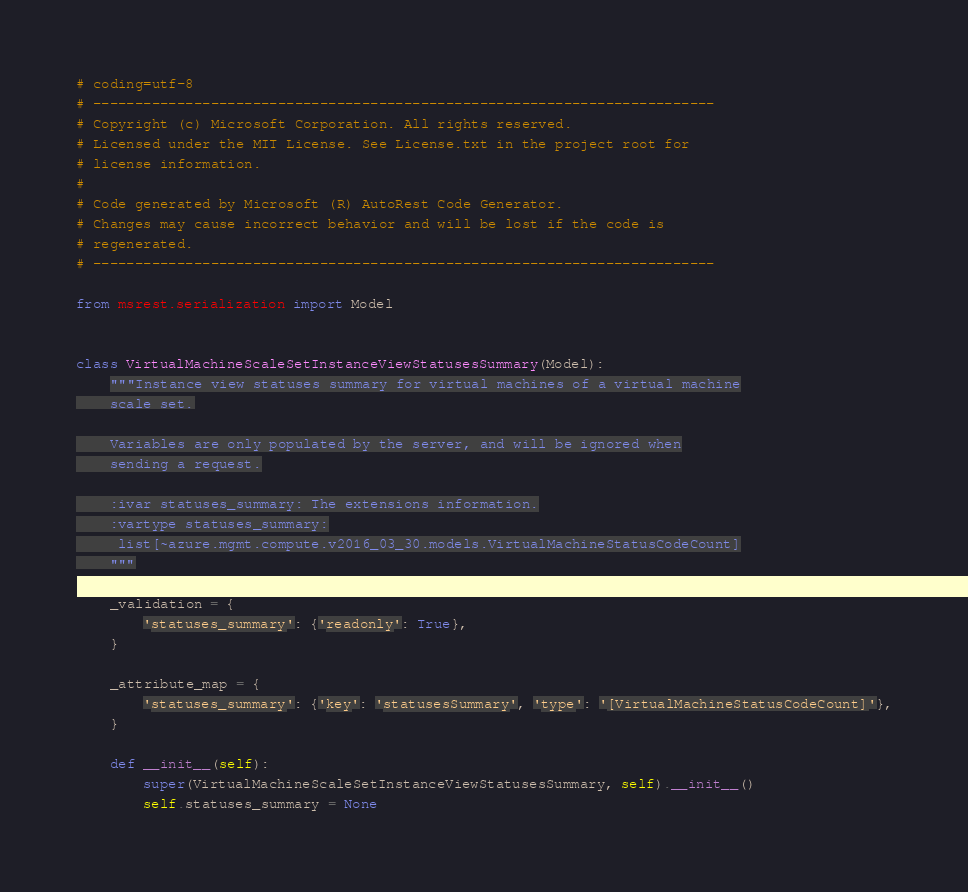<code> <loc_0><loc_0><loc_500><loc_500><_Python_># coding=utf-8
# --------------------------------------------------------------------------
# Copyright (c) Microsoft Corporation. All rights reserved.
# Licensed under the MIT License. See License.txt in the project root for
# license information.
#
# Code generated by Microsoft (R) AutoRest Code Generator.
# Changes may cause incorrect behavior and will be lost if the code is
# regenerated.
# --------------------------------------------------------------------------

from msrest.serialization import Model


class VirtualMachineScaleSetInstanceViewStatusesSummary(Model):
    """Instance view statuses summary for virtual machines of a virtual machine
    scale set.

    Variables are only populated by the server, and will be ignored when
    sending a request.

    :ivar statuses_summary: The extensions information.
    :vartype statuses_summary:
     list[~azure.mgmt.compute.v2016_03_30.models.VirtualMachineStatusCodeCount]
    """

    _validation = {
        'statuses_summary': {'readonly': True},
    }

    _attribute_map = {
        'statuses_summary': {'key': 'statusesSummary', 'type': '[VirtualMachineStatusCodeCount]'},
    }

    def __init__(self):
        super(VirtualMachineScaleSetInstanceViewStatusesSummary, self).__init__()
        self.statuses_summary = None
</code> 